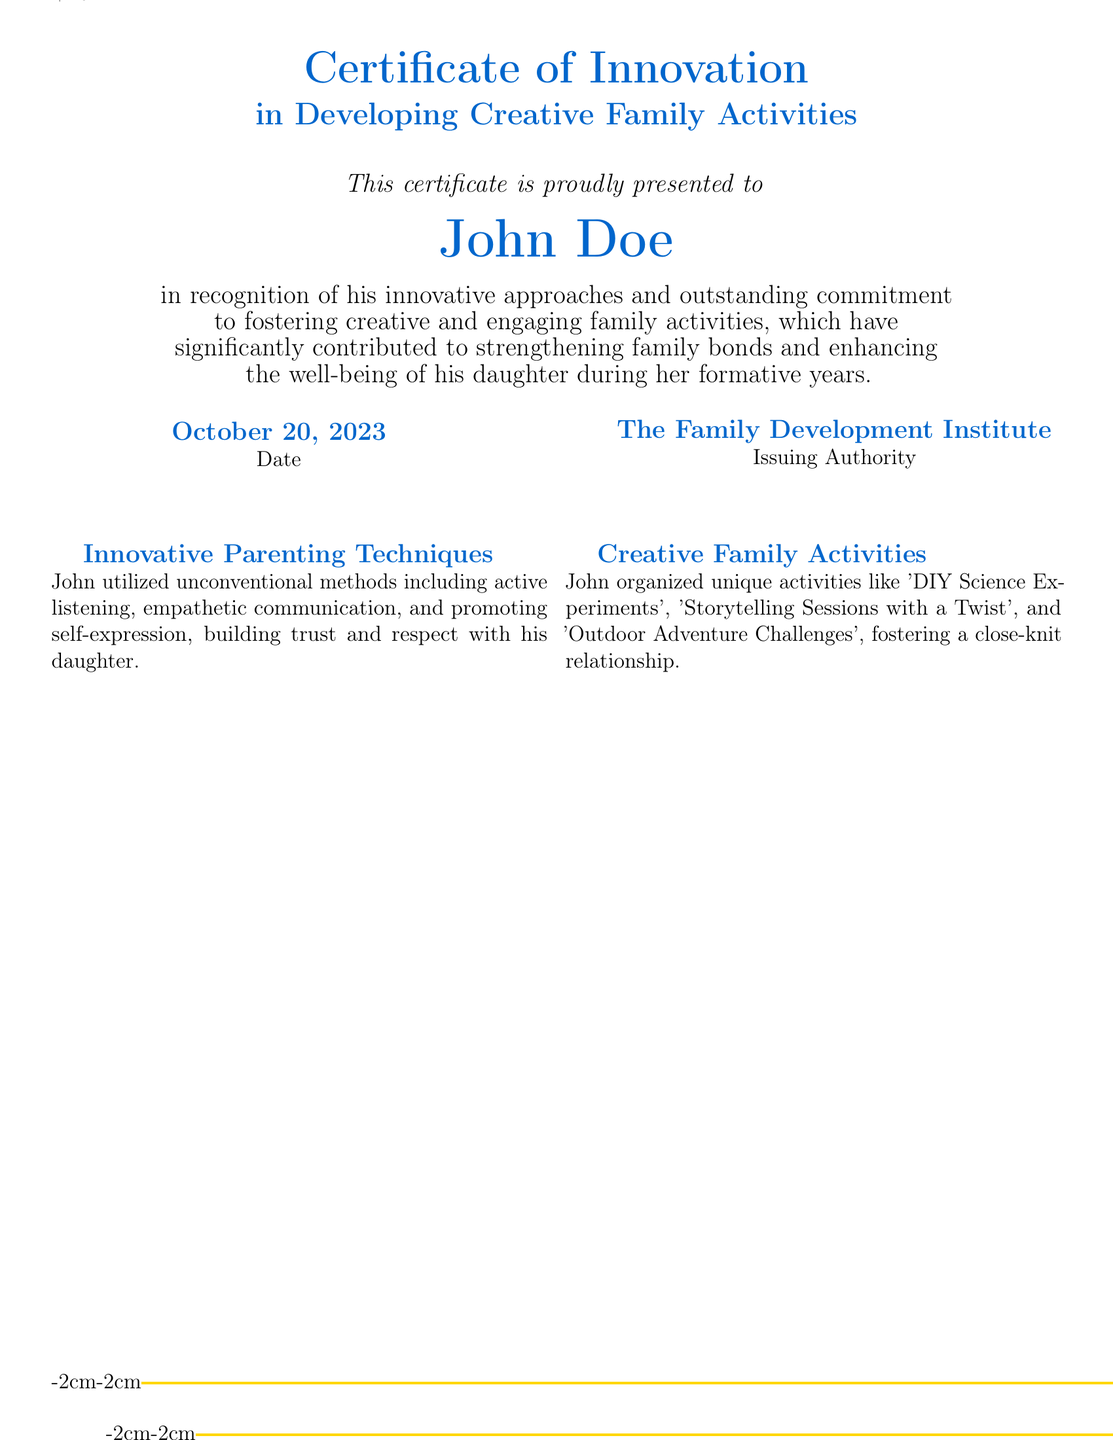What is the title of the certificate? The title of the certificate is prominently displayed at the top of the document, indicating the achievement recognized.
Answer: Certificate of Innovation in Developing Creative Family Activities Who is the certificate presented to? The recipient's name is clearly stated in the center of the certificate, showcasing the individual recognized for their achievements.
Answer: John Doe What is the date on the certificate? The date signifies when the certificate was issued, which adds context to the accomplishment.
Answer: October 20, 2023 What organization issued the certificate? The issuing authority is stated at the bottom of the certificate, indicating who endorsed the recognition.
Answer: The Family Development Institute What innovative parenting techniques did John utilize? This section lists specific approaches that highlight John's unique style of parenting based on the document's content.
Answer: Active listening, empathetic communication, and promoting self-expression What type of activities did John organize? The document specifies unique activities that John created, emphasizing his creativity in family engagement.
Answer: DIY Science Experiments, Storytelling Sessions with a Twist, Outdoor Adventure Challenges What workshop did John contribute to? The name of the workshop is mentioned, showcasing John's involvement in sharing his experiences with others.
Answer: Parenting for Tomorrow What impact did John's approaches have on his daughter? The testimonial section reflects the results of John's parenting on his daughter, highlighting the outcomes of his methods.
Answer: Profound impact What is included in the testimonial about John? The testimonial offers insights into the effects of John's parenting style and the perception of his efforts by others.
Answer: John's innovative approaches have had a profound impact 